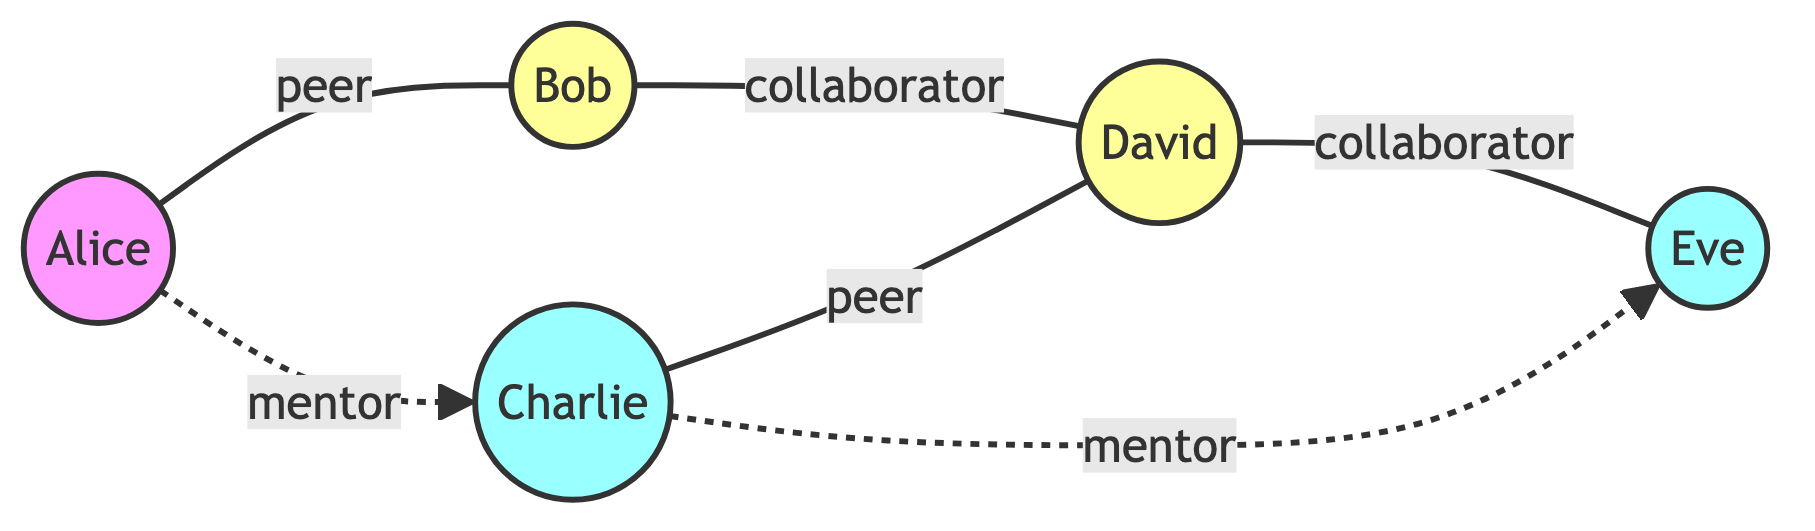What is the total number of nodes in the graph? To count the nodes, we look at the "nodes" section of the data. There are five entries: Alice, Bob, Charlie, David, and Eve. Thus, the total count is 5.
Answer: 5 Which node is connected to both Bob and David? We examine the edges. The edge from Alice to Bob indicates Alice is connected to Bob. The edge from Bob to David indicates that Bob is connected to David. Therefore, Alice is the node connected to both.
Answer: Alice What type of relationship exists between Charlie and Eve? Referring to the edges, we find an edge that connects Charlie to Eve with the label "mentor." This means the relationship type is "mentor."
Answer: mentor How many edges are labeled as "collaborator"? We look at the edges and identify the labels. The edges between Bob and David and between David and Eve are both labeled as "collaborator." Counting these gives us two edges.
Answer: 2 Who is a mentor to Charlie? In the edges section, we find that an edge exists from Charlie to Eve labeled as "mentor." This means Eve serves as a mentor to Charlie.
Answer: Eve How many unique connections does Alice have? We check the edges connected to Alice. Alice has one edge to Bob (labeled "peer") and another edge to Charlie (labeled "mentor"). Adding these connections gives us a total of two unique connections.
Answer: 2 Which node has the most connections? To determine the node with the most connections, we calculate the number of direct edges for each node. Alice is connected to Bob and Charlie (2), Bob is connected to Alice and David (2), Charlie is connected to Alice, David, and Eve (3), and David is connected to Bob and Eve (2), while Eve is only connected to Charlie and David (2). The node with the most connections is Charlie with 3 connections.
Answer: Charlie What is the relationship between Alice and Charlie? According to the edges, there is a line connecting Alice and Charlie, labeled "mentor," indicating the relationship type between them.
Answer: mentor Which two nodes are collaborators? The edges indicate collaboration between two pairs: Bob and David, and David and Eve. Both these connections labeled "collaborator" show the collaborators. Since the question asks for any two nodes, either pair can be answered.
Answer: Bob, David 